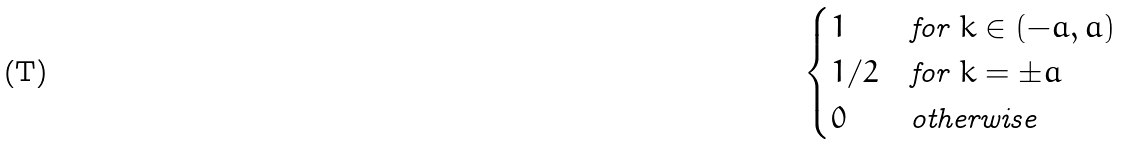Convert formula to latex. <formula><loc_0><loc_0><loc_500><loc_500>\begin{cases} 1 & \text {for $k \in (-a,a)$} \\ 1 / 2 & \text {for $k = \pm a$} \\ 0 & \text {otherwise} \quad \end{cases}</formula> 